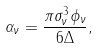Convert formula to latex. <formula><loc_0><loc_0><loc_500><loc_500>\alpha _ { \nu } = { \frac { \pi \sigma _ { \nu } ^ { 3 } \phi _ { \nu } } { 6 \Delta } , }</formula> 